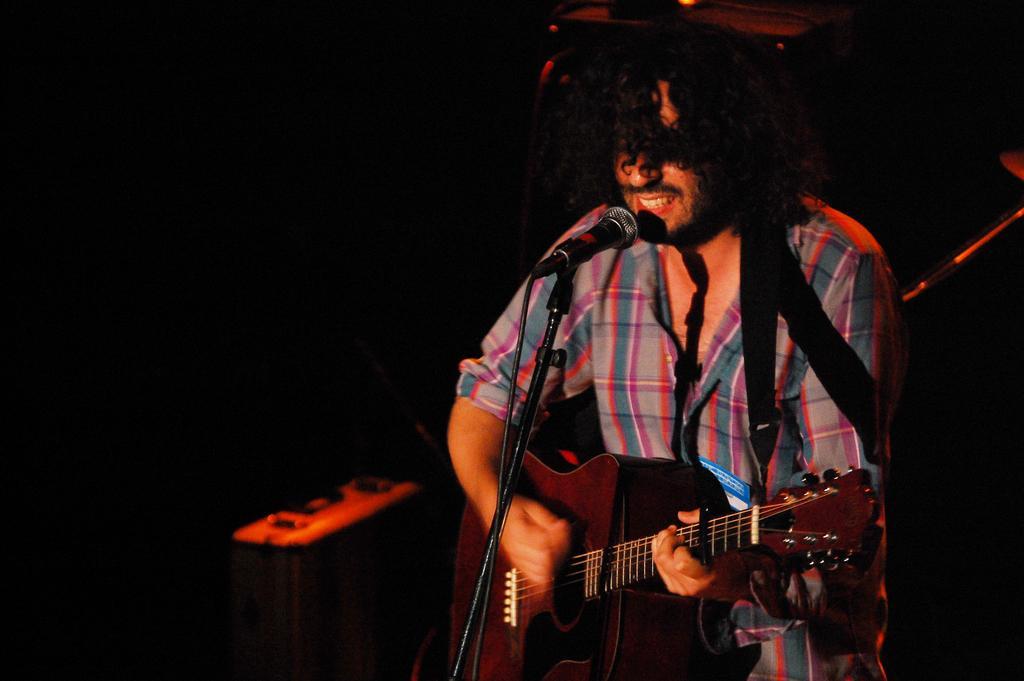Describe this image in one or two sentences. The man in grey check shirt is holding a guitar in his hands and he is playing it. In front of him, we see a microphone and he is singing the song on the microphone. In the background, it is black in color. This picture is clicked in the dark. 